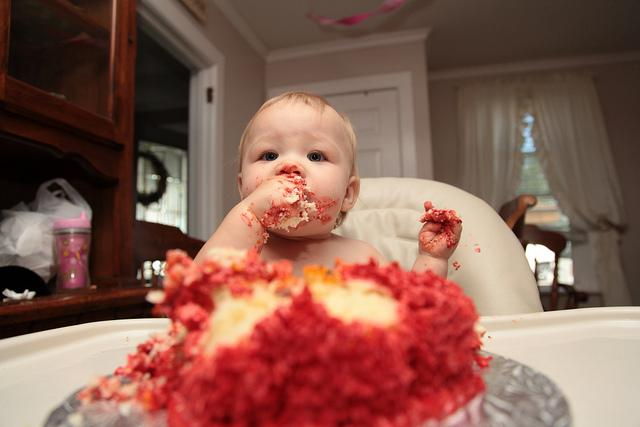What's the baby done to get so messy? Please explain your reasoning. ate food. The baby stuck her hands in the cake in front of her and has smeared cake and frosting all over her face. 